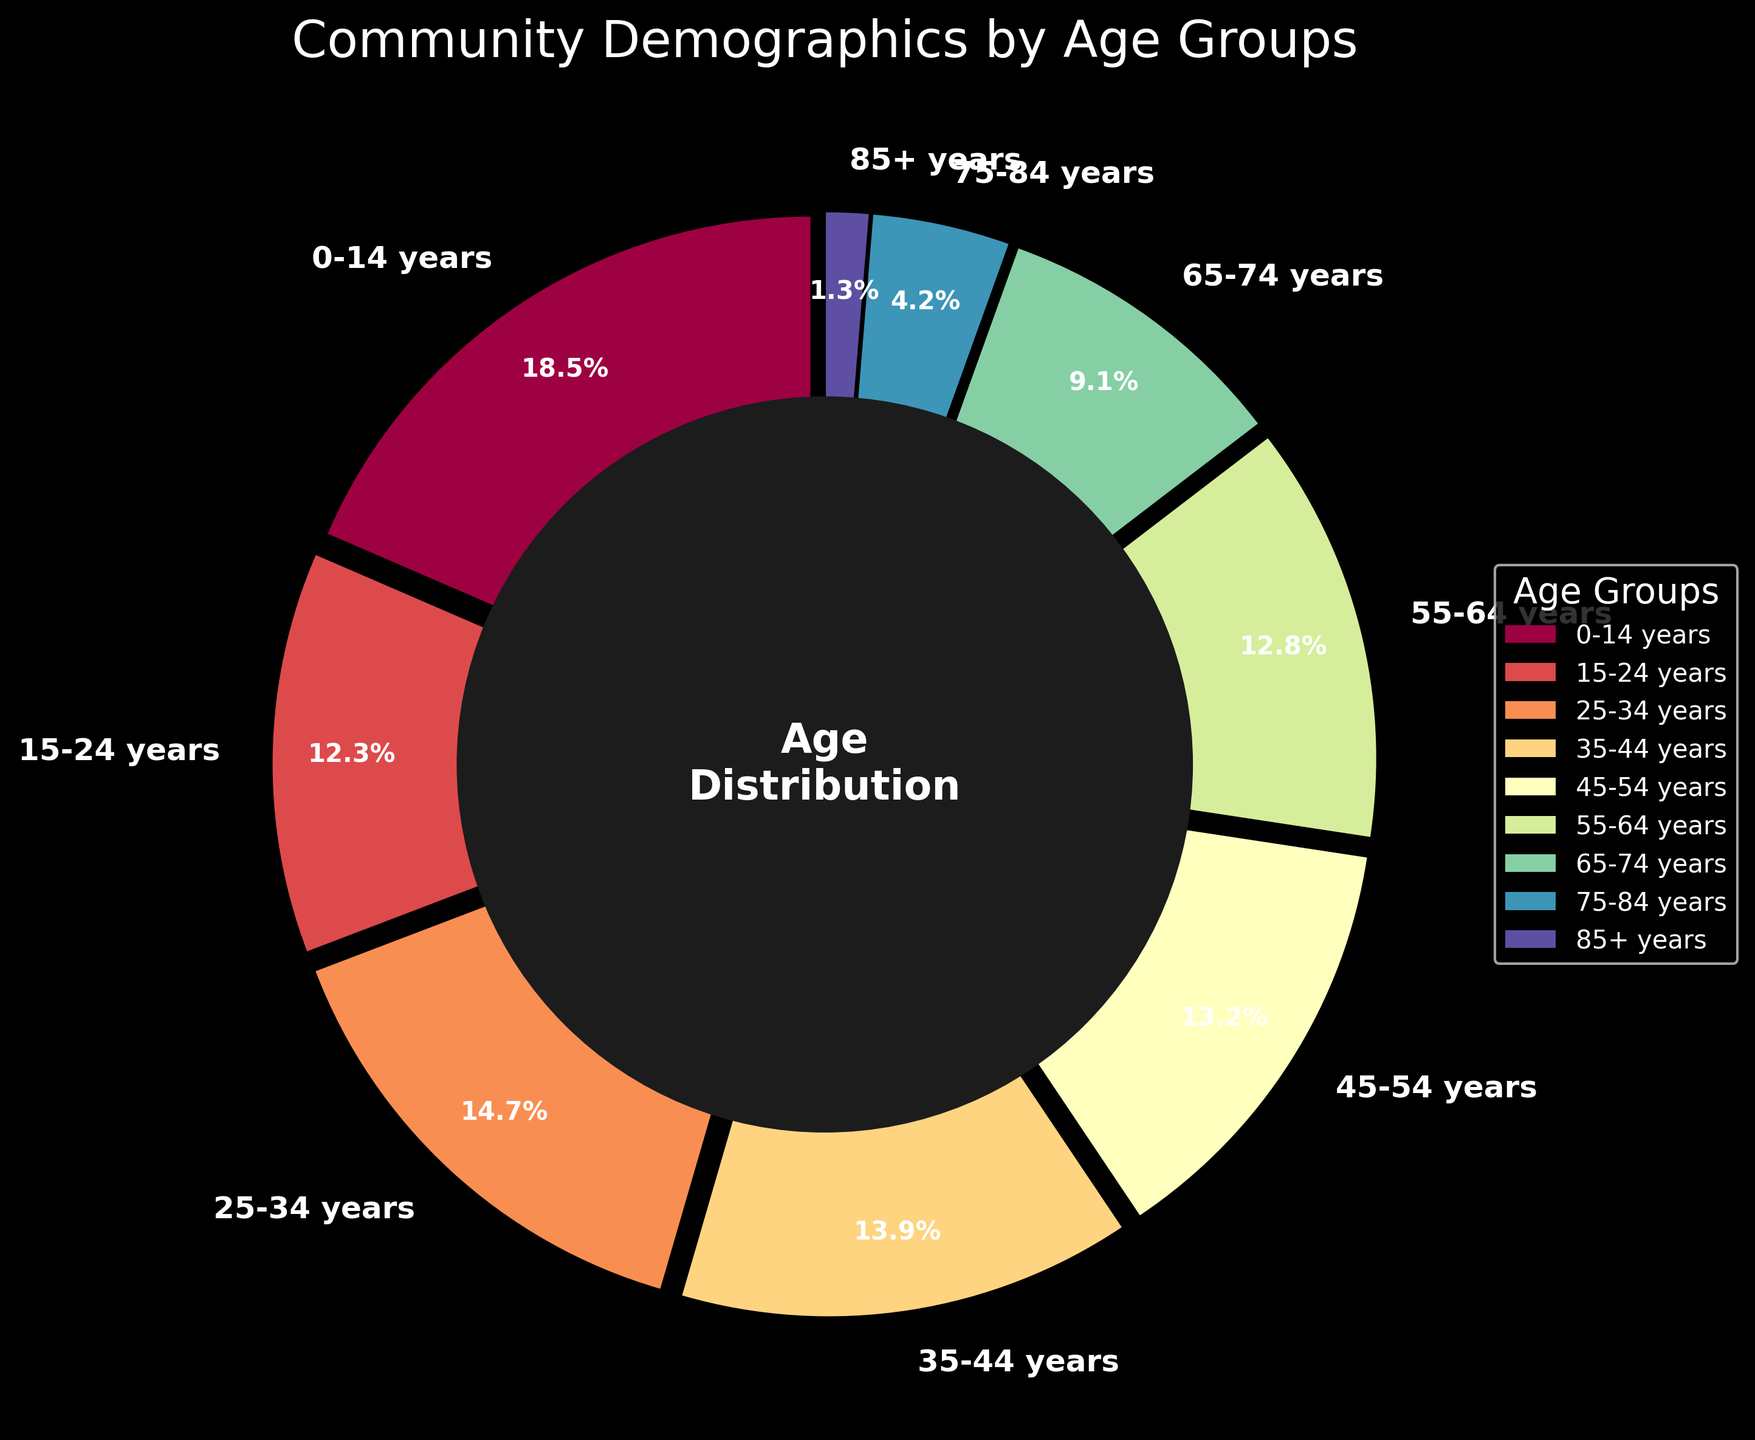Which age group has the highest percentage? To find the age group with the highest percentage, we need to look for the largest slice in the pie chart. The 0-14 years age group occupies the largest portion of the pie chart with 18.5%.
Answer: 0-14 years How many age groups have a percentage greater than 10%? By inspecting the labels and their respective percentages, we identify the age groups with percentages greater than 10%. These groups are 0-14 years, 15-24 years, 25-34 years, 35-44 years, 45-54 years, and 55-64 years.
Answer: 6 What is the combined percentage of the 65-74 years and 75-84 years age groups? We need to add the percentages of the 65-74 years and 75-84 years age groups: 9.1% (65-74 years) + 4.2% (75-84 years) = 13.3%.
Answer: 13.3% Which age group has a lower percentage, 45-54 years or 55-64 years? The percentage for 45-54 years is 13.2%, and for 55-64 years, it is 12.8%. Comparing the two, 55-64 years is lower.
Answer: 55-64 years Does the 85+ years age group have a higher percentage than the 15-24 years age group? The percentage for 85+ years is 1.3%, and for 15-24 years, it is 12.3%. Since 1.3% is less than 12.3%, 85+ years has a lower percentage.
Answer: No What is the average percentage of the age groups under 35 years? The age groups under 35 years are 0-14 years (18.5%), 15-24 years (12.3%), and 25-34 years (14.7%). The average is calculated as (18.5% + 12.3% + 14.7%) / 3 = 15.17%.
Answer: 15.17% Which color represents the 55-64 years age group? By observing the color coding in the pie chart, we can identify the color of the slice corresponding to the 55-64 years age group. It is visually distinguishable and marked with its label.
Answer: The specific color used in the plot Which age group has the smallest percentage? To find the age group with the smallest percentage, we need to look for the smallest slice in the pie chart. The 85+ years age group is the smallest with 1.3%.
Answer: 85+ years What is the percentage difference between the 0-14 years and 35-44 years age groups? To calculate the percentage difference, subtract the percentage of the 35-44 years age group from the percentage of the 0-14 years age group: 18.5% - 13.9% = 4.6%.
Answer: 4.6% How many age groups have a percentage less than 10%? By inspecting the labels and their respective percentages, we identify the age groups with percentages less than 10%. These groups are 65-74 years (9.1%), 75-84 years (4.2%), and 85+ years (1.3%).
Answer: 3 